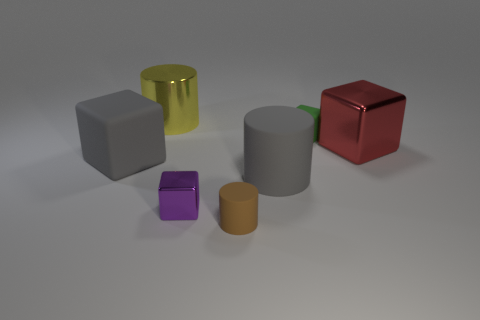There is a large yellow object that is the same material as the tiny purple cube; what is its shape?
Keep it short and to the point. Cylinder. There is a big cube that is on the right side of the big matte object on the left side of the large yellow metallic cylinder; what is its color?
Keep it short and to the point. Red. Is the color of the big cube that is in front of the large red cube the same as the large rubber cylinder?
Your response must be concise. Yes. Do the gray block and the yellow thing have the same size?
Offer a very short reply. Yes. What shape is the red thing that is the same size as the gray cube?
Keep it short and to the point. Cube. Is the size of the gray matte thing that is left of the brown object the same as the large red metallic thing?
Offer a very short reply. Yes. There is a red object that is the same size as the yellow shiny cylinder; what is its material?
Your answer should be compact. Metal. There is a purple cube in front of the tiny object behind the big red thing; are there any cubes behind it?
Keep it short and to the point. Yes. Do the large matte block in front of the green matte object and the big cylinder to the right of the yellow cylinder have the same color?
Your response must be concise. Yes. Are any blue cylinders visible?
Keep it short and to the point. No. 